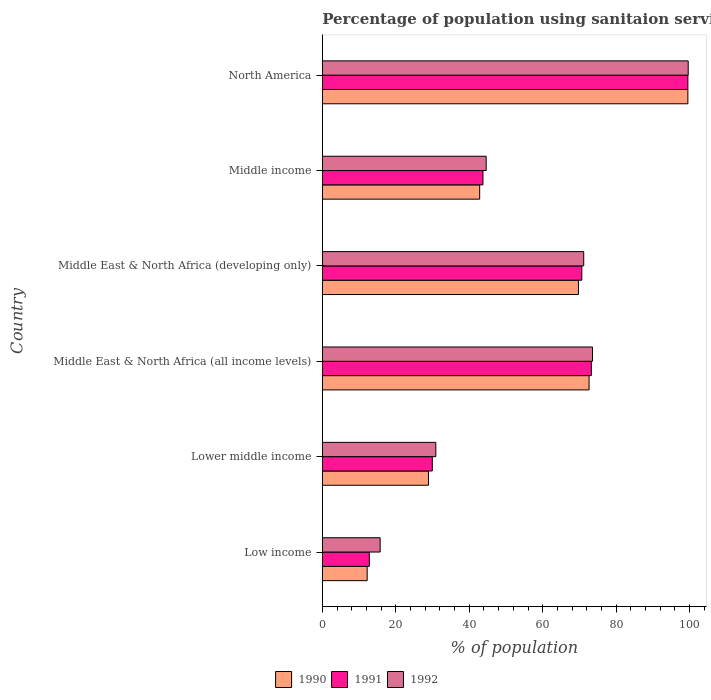Are the number of bars per tick equal to the number of legend labels?
Give a very brief answer. Yes. Are the number of bars on each tick of the Y-axis equal?
Your response must be concise. Yes. How many bars are there on the 2nd tick from the top?
Offer a terse response. 3. What is the label of the 5th group of bars from the top?
Offer a terse response. Lower middle income. What is the percentage of population using sanitaion services in 1992 in Middle East & North Africa (developing only)?
Provide a succinct answer. 71.17. Across all countries, what is the maximum percentage of population using sanitaion services in 1992?
Provide a short and direct response. 99.62. Across all countries, what is the minimum percentage of population using sanitaion services in 1992?
Provide a short and direct response. 15.74. What is the total percentage of population using sanitaion services in 1991 in the graph?
Your answer should be compact. 329.9. What is the difference between the percentage of population using sanitaion services in 1991 in Low income and that in Middle income?
Keep it short and to the point. -30.94. What is the difference between the percentage of population using sanitaion services in 1990 in Low income and the percentage of population using sanitaion services in 1991 in Middle East & North Africa (all income levels)?
Give a very brief answer. -61.03. What is the average percentage of population using sanitaion services in 1990 per country?
Your answer should be very brief. 54.31. What is the difference between the percentage of population using sanitaion services in 1991 and percentage of population using sanitaion services in 1990 in North America?
Your answer should be very brief. 6.557304203624881e-6. In how many countries, is the percentage of population using sanitaion services in 1992 greater than 68 %?
Your answer should be compact. 3. What is the ratio of the percentage of population using sanitaion services in 1992 in Low income to that in North America?
Your answer should be very brief. 0.16. Is the percentage of population using sanitaion services in 1992 in Low income less than that in Middle East & North Africa (developing only)?
Your answer should be very brief. Yes. What is the difference between the highest and the second highest percentage of population using sanitaion services in 1990?
Ensure brevity in your answer.  26.9. What is the difference between the highest and the lowest percentage of population using sanitaion services in 1991?
Provide a short and direct response. 86.73. Is the sum of the percentage of population using sanitaion services in 1992 in Middle income and North America greater than the maximum percentage of population using sanitaion services in 1991 across all countries?
Ensure brevity in your answer.  Yes. Is it the case that in every country, the sum of the percentage of population using sanitaion services in 1992 and percentage of population using sanitaion services in 1991 is greater than the percentage of population using sanitaion services in 1990?
Make the answer very short. Yes. How many bars are there?
Your response must be concise. 18. How many countries are there in the graph?
Your response must be concise. 6. What is the difference between two consecutive major ticks on the X-axis?
Make the answer very short. 20. Are the values on the major ticks of X-axis written in scientific E-notation?
Your response must be concise. No. Does the graph contain any zero values?
Make the answer very short. No. Does the graph contain grids?
Offer a terse response. No. How many legend labels are there?
Make the answer very short. 3. How are the legend labels stacked?
Your response must be concise. Horizontal. What is the title of the graph?
Your answer should be very brief. Percentage of population using sanitaion services. Does "1990" appear as one of the legend labels in the graph?
Offer a very short reply. Yes. What is the label or title of the X-axis?
Offer a very short reply. % of population. What is the label or title of the Y-axis?
Offer a terse response. Country. What is the % of population in 1990 in Low income?
Ensure brevity in your answer.  12.21. What is the % of population of 1991 in Low income?
Make the answer very short. 12.8. What is the % of population of 1992 in Low income?
Keep it short and to the point. 15.74. What is the % of population of 1990 in Lower middle income?
Provide a short and direct response. 28.9. What is the % of population in 1991 in Lower middle income?
Give a very brief answer. 29.95. What is the % of population of 1992 in Lower middle income?
Ensure brevity in your answer.  30.9. What is the % of population in 1990 in Middle East & North Africa (all income levels)?
Make the answer very short. 72.63. What is the % of population of 1991 in Middle East & North Africa (all income levels)?
Provide a short and direct response. 73.24. What is the % of population in 1992 in Middle East & North Africa (all income levels)?
Keep it short and to the point. 73.56. What is the % of population in 1990 in Middle East & North Africa (developing only)?
Your answer should be compact. 69.74. What is the % of population in 1991 in Middle East & North Africa (developing only)?
Offer a terse response. 70.65. What is the % of population in 1992 in Middle East & North Africa (developing only)?
Provide a short and direct response. 71.17. What is the % of population of 1990 in Middle income?
Offer a very short reply. 42.84. What is the % of population in 1991 in Middle income?
Give a very brief answer. 43.74. What is the % of population in 1992 in Middle income?
Your answer should be compact. 44.61. What is the % of population of 1990 in North America?
Provide a short and direct response. 99.53. What is the % of population of 1991 in North America?
Provide a succinct answer. 99.53. What is the % of population in 1992 in North America?
Provide a short and direct response. 99.62. Across all countries, what is the maximum % of population of 1990?
Offer a terse response. 99.53. Across all countries, what is the maximum % of population in 1991?
Offer a terse response. 99.53. Across all countries, what is the maximum % of population in 1992?
Provide a succinct answer. 99.62. Across all countries, what is the minimum % of population of 1990?
Provide a succinct answer. 12.21. Across all countries, what is the minimum % of population in 1991?
Your answer should be compact. 12.8. Across all countries, what is the minimum % of population of 1992?
Ensure brevity in your answer.  15.74. What is the total % of population of 1990 in the graph?
Your answer should be compact. 325.85. What is the total % of population in 1991 in the graph?
Your answer should be very brief. 329.9. What is the total % of population of 1992 in the graph?
Your answer should be compact. 335.61. What is the difference between the % of population of 1990 in Low income and that in Lower middle income?
Offer a terse response. -16.69. What is the difference between the % of population of 1991 in Low income and that in Lower middle income?
Offer a very short reply. -17.15. What is the difference between the % of population of 1992 in Low income and that in Lower middle income?
Provide a succinct answer. -15.16. What is the difference between the % of population in 1990 in Low income and that in Middle East & North Africa (all income levels)?
Ensure brevity in your answer.  -60.42. What is the difference between the % of population of 1991 in Low income and that in Middle East & North Africa (all income levels)?
Your answer should be very brief. -60.45. What is the difference between the % of population in 1992 in Low income and that in Middle East & North Africa (all income levels)?
Give a very brief answer. -57.82. What is the difference between the % of population in 1990 in Low income and that in Middle East & North Africa (developing only)?
Provide a succinct answer. -57.53. What is the difference between the % of population in 1991 in Low income and that in Middle East & North Africa (developing only)?
Give a very brief answer. -57.86. What is the difference between the % of population in 1992 in Low income and that in Middle East & North Africa (developing only)?
Give a very brief answer. -55.43. What is the difference between the % of population of 1990 in Low income and that in Middle income?
Make the answer very short. -30.63. What is the difference between the % of population of 1991 in Low income and that in Middle income?
Your answer should be compact. -30.94. What is the difference between the % of population of 1992 in Low income and that in Middle income?
Give a very brief answer. -28.87. What is the difference between the % of population in 1990 in Low income and that in North America?
Offer a very short reply. -87.32. What is the difference between the % of population in 1991 in Low income and that in North America?
Your answer should be very brief. -86.73. What is the difference between the % of population in 1992 in Low income and that in North America?
Provide a succinct answer. -83.88. What is the difference between the % of population in 1990 in Lower middle income and that in Middle East & North Africa (all income levels)?
Your answer should be very brief. -43.73. What is the difference between the % of population in 1991 in Lower middle income and that in Middle East & North Africa (all income levels)?
Provide a short and direct response. -43.3. What is the difference between the % of population of 1992 in Lower middle income and that in Middle East & North Africa (all income levels)?
Provide a succinct answer. -42.66. What is the difference between the % of population of 1990 in Lower middle income and that in Middle East & North Africa (developing only)?
Offer a terse response. -40.84. What is the difference between the % of population of 1991 in Lower middle income and that in Middle East & North Africa (developing only)?
Your response must be concise. -40.71. What is the difference between the % of population in 1992 in Lower middle income and that in Middle East & North Africa (developing only)?
Provide a succinct answer. -40.27. What is the difference between the % of population of 1990 in Lower middle income and that in Middle income?
Your answer should be compact. -13.94. What is the difference between the % of population of 1991 in Lower middle income and that in Middle income?
Your response must be concise. -13.79. What is the difference between the % of population in 1992 in Lower middle income and that in Middle income?
Provide a succinct answer. -13.71. What is the difference between the % of population of 1990 in Lower middle income and that in North America?
Make the answer very short. -70.63. What is the difference between the % of population of 1991 in Lower middle income and that in North America?
Give a very brief answer. -69.58. What is the difference between the % of population of 1992 in Lower middle income and that in North America?
Provide a short and direct response. -68.72. What is the difference between the % of population in 1990 in Middle East & North Africa (all income levels) and that in Middle East & North Africa (developing only)?
Offer a very short reply. 2.89. What is the difference between the % of population in 1991 in Middle East & North Africa (all income levels) and that in Middle East & North Africa (developing only)?
Offer a very short reply. 2.59. What is the difference between the % of population of 1992 in Middle East & North Africa (all income levels) and that in Middle East & North Africa (developing only)?
Your response must be concise. 2.39. What is the difference between the % of population of 1990 in Middle East & North Africa (all income levels) and that in Middle income?
Give a very brief answer. 29.79. What is the difference between the % of population in 1991 in Middle East & North Africa (all income levels) and that in Middle income?
Make the answer very short. 29.51. What is the difference between the % of population of 1992 in Middle East & North Africa (all income levels) and that in Middle income?
Your answer should be very brief. 28.95. What is the difference between the % of population of 1990 in Middle East & North Africa (all income levels) and that in North America?
Keep it short and to the point. -26.9. What is the difference between the % of population in 1991 in Middle East & North Africa (all income levels) and that in North America?
Provide a short and direct response. -26.29. What is the difference between the % of population in 1992 in Middle East & North Africa (all income levels) and that in North America?
Make the answer very short. -26.06. What is the difference between the % of population of 1990 in Middle East & North Africa (developing only) and that in Middle income?
Give a very brief answer. 26.9. What is the difference between the % of population of 1991 in Middle East & North Africa (developing only) and that in Middle income?
Ensure brevity in your answer.  26.92. What is the difference between the % of population of 1992 in Middle East & North Africa (developing only) and that in Middle income?
Offer a terse response. 26.56. What is the difference between the % of population of 1990 in Middle East & North Africa (developing only) and that in North America?
Ensure brevity in your answer.  -29.79. What is the difference between the % of population of 1991 in Middle East & North Africa (developing only) and that in North America?
Offer a very short reply. -28.88. What is the difference between the % of population in 1992 in Middle East & North Africa (developing only) and that in North America?
Offer a very short reply. -28.45. What is the difference between the % of population in 1990 in Middle income and that in North America?
Provide a succinct answer. -56.69. What is the difference between the % of population of 1991 in Middle income and that in North America?
Make the answer very short. -55.79. What is the difference between the % of population of 1992 in Middle income and that in North America?
Make the answer very short. -55.01. What is the difference between the % of population of 1990 in Low income and the % of population of 1991 in Lower middle income?
Provide a succinct answer. -17.74. What is the difference between the % of population of 1990 in Low income and the % of population of 1992 in Lower middle income?
Ensure brevity in your answer.  -18.69. What is the difference between the % of population in 1991 in Low income and the % of population in 1992 in Lower middle income?
Offer a terse response. -18.11. What is the difference between the % of population in 1990 in Low income and the % of population in 1991 in Middle East & North Africa (all income levels)?
Your answer should be very brief. -61.03. What is the difference between the % of population in 1990 in Low income and the % of population in 1992 in Middle East & North Africa (all income levels)?
Ensure brevity in your answer.  -61.35. What is the difference between the % of population of 1991 in Low income and the % of population of 1992 in Middle East & North Africa (all income levels)?
Your answer should be very brief. -60.76. What is the difference between the % of population in 1990 in Low income and the % of population in 1991 in Middle East & North Africa (developing only)?
Your answer should be very brief. -58.45. What is the difference between the % of population in 1990 in Low income and the % of population in 1992 in Middle East & North Africa (developing only)?
Your answer should be very brief. -58.96. What is the difference between the % of population of 1991 in Low income and the % of population of 1992 in Middle East & North Africa (developing only)?
Ensure brevity in your answer.  -58.37. What is the difference between the % of population in 1990 in Low income and the % of population in 1991 in Middle income?
Provide a succinct answer. -31.53. What is the difference between the % of population of 1990 in Low income and the % of population of 1992 in Middle income?
Make the answer very short. -32.4. What is the difference between the % of population of 1991 in Low income and the % of population of 1992 in Middle income?
Your response must be concise. -31.82. What is the difference between the % of population of 1990 in Low income and the % of population of 1991 in North America?
Your answer should be very brief. -87.32. What is the difference between the % of population in 1990 in Low income and the % of population in 1992 in North America?
Your answer should be very brief. -87.41. What is the difference between the % of population of 1991 in Low income and the % of population of 1992 in North America?
Give a very brief answer. -86.82. What is the difference between the % of population of 1990 in Lower middle income and the % of population of 1991 in Middle East & North Africa (all income levels)?
Make the answer very short. -44.34. What is the difference between the % of population of 1990 in Lower middle income and the % of population of 1992 in Middle East & North Africa (all income levels)?
Your answer should be compact. -44.66. What is the difference between the % of population of 1991 in Lower middle income and the % of population of 1992 in Middle East & North Africa (all income levels)?
Offer a very short reply. -43.62. What is the difference between the % of population in 1990 in Lower middle income and the % of population in 1991 in Middle East & North Africa (developing only)?
Offer a very short reply. -41.75. What is the difference between the % of population in 1990 in Lower middle income and the % of population in 1992 in Middle East & North Africa (developing only)?
Keep it short and to the point. -42.27. What is the difference between the % of population of 1991 in Lower middle income and the % of population of 1992 in Middle East & North Africa (developing only)?
Your answer should be very brief. -41.23. What is the difference between the % of population of 1990 in Lower middle income and the % of population of 1991 in Middle income?
Your answer should be compact. -14.84. What is the difference between the % of population of 1990 in Lower middle income and the % of population of 1992 in Middle income?
Your answer should be compact. -15.71. What is the difference between the % of population in 1991 in Lower middle income and the % of population in 1992 in Middle income?
Offer a very short reply. -14.67. What is the difference between the % of population in 1990 in Lower middle income and the % of population in 1991 in North America?
Your answer should be very brief. -70.63. What is the difference between the % of population of 1990 in Lower middle income and the % of population of 1992 in North America?
Keep it short and to the point. -70.72. What is the difference between the % of population of 1991 in Lower middle income and the % of population of 1992 in North America?
Give a very brief answer. -69.67. What is the difference between the % of population of 1990 in Middle East & North Africa (all income levels) and the % of population of 1991 in Middle East & North Africa (developing only)?
Offer a very short reply. 1.98. What is the difference between the % of population in 1990 in Middle East & North Africa (all income levels) and the % of population in 1992 in Middle East & North Africa (developing only)?
Make the answer very short. 1.46. What is the difference between the % of population of 1991 in Middle East & North Africa (all income levels) and the % of population of 1992 in Middle East & North Africa (developing only)?
Your answer should be compact. 2.07. What is the difference between the % of population of 1990 in Middle East & North Africa (all income levels) and the % of population of 1991 in Middle income?
Your answer should be very brief. 28.89. What is the difference between the % of population of 1990 in Middle East & North Africa (all income levels) and the % of population of 1992 in Middle income?
Keep it short and to the point. 28.02. What is the difference between the % of population of 1991 in Middle East & North Africa (all income levels) and the % of population of 1992 in Middle income?
Give a very brief answer. 28.63. What is the difference between the % of population in 1990 in Middle East & North Africa (all income levels) and the % of population in 1991 in North America?
Your response must be concise. -26.9. What is the difference between the % of population in 1990 in Middle East & North Africa (all income levels) and the % of population in 1992 in North America?
Your answer should be very brief. -26.99. What is the difference between the % of population in 1991 in Middle East & North Africa (all income levels) and the % of population in 1992 in North America?
Your response must be concise. -26.38. What is the difference between the % of population in 1990 in Middle East & North Africa (developing only) and the % of population in 1991 in Middle income?
Keep it short and to the point. 26. What is the difference between the % of population of 1990 in Middle East & North Africa (developing only) and the % of population of 1992 in Middle income?
Keep it short and to the point. 25.13. What is the difference between the % of population in 1991 in Middle East & North Africa (developing only) and the % of population in 1992 in Middle income?
Your answer should be compact. 26.04. What is the difference between the % of population in 1990 in Middle East & North Africa (developing only) and the % of population in 1991 in North America?
Your response must be concise. -29.79. What is the difference between the % of population of 1990 in Middle East & North Africa (developing only) and the % of population of 1992 in North America?
Keep it short and to the point. -29.88. What is the difference between the % of population in 1991 in Middle East & North Africa (developing only) and the % of population in 1992 in North America?
Give a very brief answer. -28.97. What is the difference between the % of population in 1990 in Middle income and the % of population in 1991 in North America?
Keep it short and to the point. -56.69. What is the difference between the % of population of 1990 in Middle income and the % of population of 1992 in North America?
Your answer should be compact. -56.78. What is the difference between the % of population of 1991 in Middle income and the % of population of 1992 in North America?
Make the answer very short. -55.88. What is the average % of population of 1990 per country?
Ensure brevity in your answer.  54.31. What is the average % of population in 1991 per country?
Your response must be concise. 54.98. What is the average % of population in 1992 per country?
Provide a succinct answer. 55.93. What is the difference between the % of population of 1990 and % of population of 1991 in Low income?
Give a very brief answer. -0.59. What is the difference between the % of population in 1990 and % of population in 1992 in Low income?
Provide a succinct answer. -3.53. What is the difference between the % of population of 1991 and % of population of 1992 in Low income?
Keep it short and to the point. -2.94. What is the difference between the % of population in 1990 and % of population in 1991 in Lower middle income?
Make the answer very short. -1.04. What is the difference between the % of population in 1990 and % of population in 1992 in Lower middle income?
Ensure brevity in your answer.  -2. What is the difference between the % of population of 1991 and % of population of 1992 in Lower middle income?
Keep it short and to the point. -0.96. What is the difference between the % of population of 1990 and % of population of 1991 in Middle East & North Africa (all income levels)?
Your answer should be very brief. -0.61. What is the difference between the % of population of 1990 and % of population of 1992 in Middle East & North Africa (all income levels)?
Offer a very short reply. -0.93. What is the difference between the % of population in 1991 and % of population in 1992 in Middle East & North Africa (all income levels)?
Your answer should be compact. -0.32. What is the difference between the % of population of 1990 and % of population of 1991 in Middle East & North Africa (developing only)?
Offer a very short reply. -0.91. What is the difference between the % of population in 1990 and % of population in 1992 in Middle East & North Africa (developing only)?
Your response must be concise. -1.43. What is the difference between the % of population in 1991 and % of population in 1992 in Middle East & North Africa (developing only)?
Give a very brief answer. -0.52. What is the difference between the % of population of 1990 and % of population of 1991 in Middle income?
Give a very brief answer. -0.89. What is the difference between the % of population of 1990 and % of population of 1992 in Middle income?
Provide a short and direct response. -1.77. What is the difference between the % of population in 1991 and % of population in 1992 in Middle income?
Keep it short and to the point. -0.88. What is the difference between the % of population in 1990 and % of population in 1991 in North America?
Give a very brief answer. -0. What is the difference between the % of population in 1990 and % of population in 1992 in North America?
Give a very brief answer. -0.09. What is the difference between the % of population in 1991 and % of population in 1992 in North America?
Give a very brief answer. -0.09. What is the ratio of the % of population of 1990 in Low income to that in Lower middle income?
Provide a short and direct response. 0.42. What is the ratio of the % of population of 1991 in Low income to that in Lower middle income?
Provide a succinct answer. 0.43. What is the ratio of the % of population of 1992 in Low income to that in Lower middle income?
Give a very brief answer. 0.51. What is the ratio of the % of population of 1990 in Low income to that in Middle East & North Africa (all income levels)?
Give a very brief answer. 0.17. What is the ratio of the % of population in 1991 in Low income to that in Middle East & North Africa (all income levels)?
Your answer should be very brief. 0.17. What is the ratio of the % of population in 1992 in Low income to that in Middle East & North Africa (all income levels)?
Provide a succinct answer. 0.21. What is the ratio of the % of population of 1990 in Low income to that in Middle East & North Africa (developing only)?
Your answer should be compact. 0.18. What is the ratio of the % of population in 1991 in Low income to that in Middle East & North Africa (developing only)?
Keep it short and to the point. 0.18. What is the ratio of the % of population of 1992 in Low income to that in Middle East & North Africa (developing only)?
Provide a short and direct response. 0.22. What is the ratio of the % of population of 1990 in Low income to that in Middle income?
Your answer should be very brief. 0.28. What is the ratio of the % of population in 1991 in Low income to that in Middle income?
Offer a terse response. 0.29. What is the ratio of the % of population of 1992 in Low income to that in Middle income?
Give a very brief answer. 0.35. What is the ratio of the % of population of 1990 in Low income to that in North America?
Give a very brief answer. 0.12. What is the ratio of the % of population of 1991 in Low income to that in North America?
Make the answer very short. 0.13. What is the ratio of the % of population in 1992 in Low income to that in North America?
Offer a terse response. 0.16. What is the ratio of the % of population in 1990 in Lower middle income to that in Middle East & North Africa (all income levels)?
Provide a short and direct response. 0.4. What is the ratio of the % of population of 1991 in Lower middle income to that in Middle East & North Africa (all income levels)?
Offer a very short reply. 0.41. What is the ratio of the % of population of 1992 in Lower middle income to that in Middle East & North Africa (all income levels)?
Offer a terse response. 0.42. What is the ratio of the % of population in 1990 in Lower middle income to that in Middle East & North Africa (developing only)?
Provide a succinct answer. 0.41. What is the ratio of the % of population of 1991 in Lower middle income to that in Middle East & North Africa (developing only)?
Keep it short and to the point. 0.42. What is the ratio of the % of population in 1992 in Lower middle income to that in Middle East & North Africa (developing only)?
Provide a short and direct response. 0.43. What is the ratio of the % of population in 1990 in Lower middle income to that in Middle income?
Provide a short and direct response. 0.67. What is the ratio of the % of population of 1991 in Lower middle income to that in Middle income?
Your answer should be very brief. 0.68. What is the ratio of the % of population of 1992 in Lower middle income to that in Middle income?
Ensure brevity in your answer.  0.69. What is the ratio of the % of population in 1990 in Lower middle income to that in North America?
Give a very brief answer. 0.29. What is the ratio of the % of population of 1991 in Lower middle income to that in North America?
Your response must be concise. 0.3. What is the ratio of the % of population of 1992 in Lower middle income to that in North America?
Your response must be concise. 0.31. What is the ratio of the % of population in 1990 in Middle East & North Africa (all income levels) to that in Middle East & North Africa (developing only)?
Provide a succinct answer. 1.04. What is the ratio of the % of population in 1991 in Middle East & North Africa (all income levels) to that in Middle East & North Africa (developing only)?
Your answer should be very brief. 1.04. What is the ratio of the % of population of 1992 in Middle East & North Africa (all income levels) to that in Middle East & North Africa (developing only)?
Your response must be concise. 1.03. What is the ratio of the % of population of 1990 in Middle East & North Africa (all income levels) to that in Middle income?
Your response must be concise. 1.7. What is the ratio of the % of population of 1991 in Middle East & North Africa (all income levels) to that in Middle income?
Ensure brevity in your answer.  1.67. What is the ratio of the % of population of 1992 in Middle East & North Africa (all income levels) to that in Middle income?
Provide a short and direct response. 1.65. What is the ratio of the % of population of 1990 in Middle East & North Africa (all income levels) to that in North America?
Offer a terse response. 0.73. What is the ratio of the % of population in 1991 in Middle East & North Africa (all income levels) to that in North America?
Your answer should be compact. 0.74. What is the ratio of the % of population in 1992 in Middle East & North Africa (all income levels) to that in North America?
Your answer should be compact. 0.74. What is the ratio of the % of population in 1990 in Middle East & North Africa (developing only) to that in Middle income?
Make the answer very short. 1.63. What is the ratio of the % of population of 1991 in Middle East & North Africa (developing only) to that in Middle income?
Your answer should be compact. 1.62. What is the ratio of the % of population of 1992 in Middle East & North Africa (developing only) to that in Middle income?
Offer a very short reply. 1.6. What is the ratio of the % of population of 1990 in Middle East & North Africa (developing only) to that in North America?
Your answer should be very brief. 0.7. What is the ratio of the % of population of 1991 in Middle East & North Africa (developing only) to that in North America?
Offer a very short reply. 0.71. What is the ratio of the % of population of 1992 in Middle East & North Africa (developing only) to that in North America?
Provide a short and direct response. 0.71. What is the ratio of the % of population in 1990 in Middle income to that in North America?
Offer a very short reply. 0.43. What is the ratio of the % of population of 1991 in Middle income to that in North America?
Provide a succinct answer. 0.44. What is the ratio of the % of population of 1992 in Middle income to that in North America?
Ensure brevity in your answer.  0.45. What is the difference between the highest and the second highest % of population in 1990?
Ensure brevity in your answer.  26.9. What is the difference between the highest and the second highest % of population of 1991?
Provide a short and direct response. 26.29. What is the difference between the highest and the second highest % of population in 1992?
Make the answer very short. 26.06. What is the difference between the highest and the lowest % of population of 1990?
Your answer should be very brief. 87.32. What is the difference between the highest and the lowest % of population of 1991?
Your response must be concise. 86.73. What is the difference between the highest and the lowest % of population in 1992?
Your response must be concise. 83.88. 